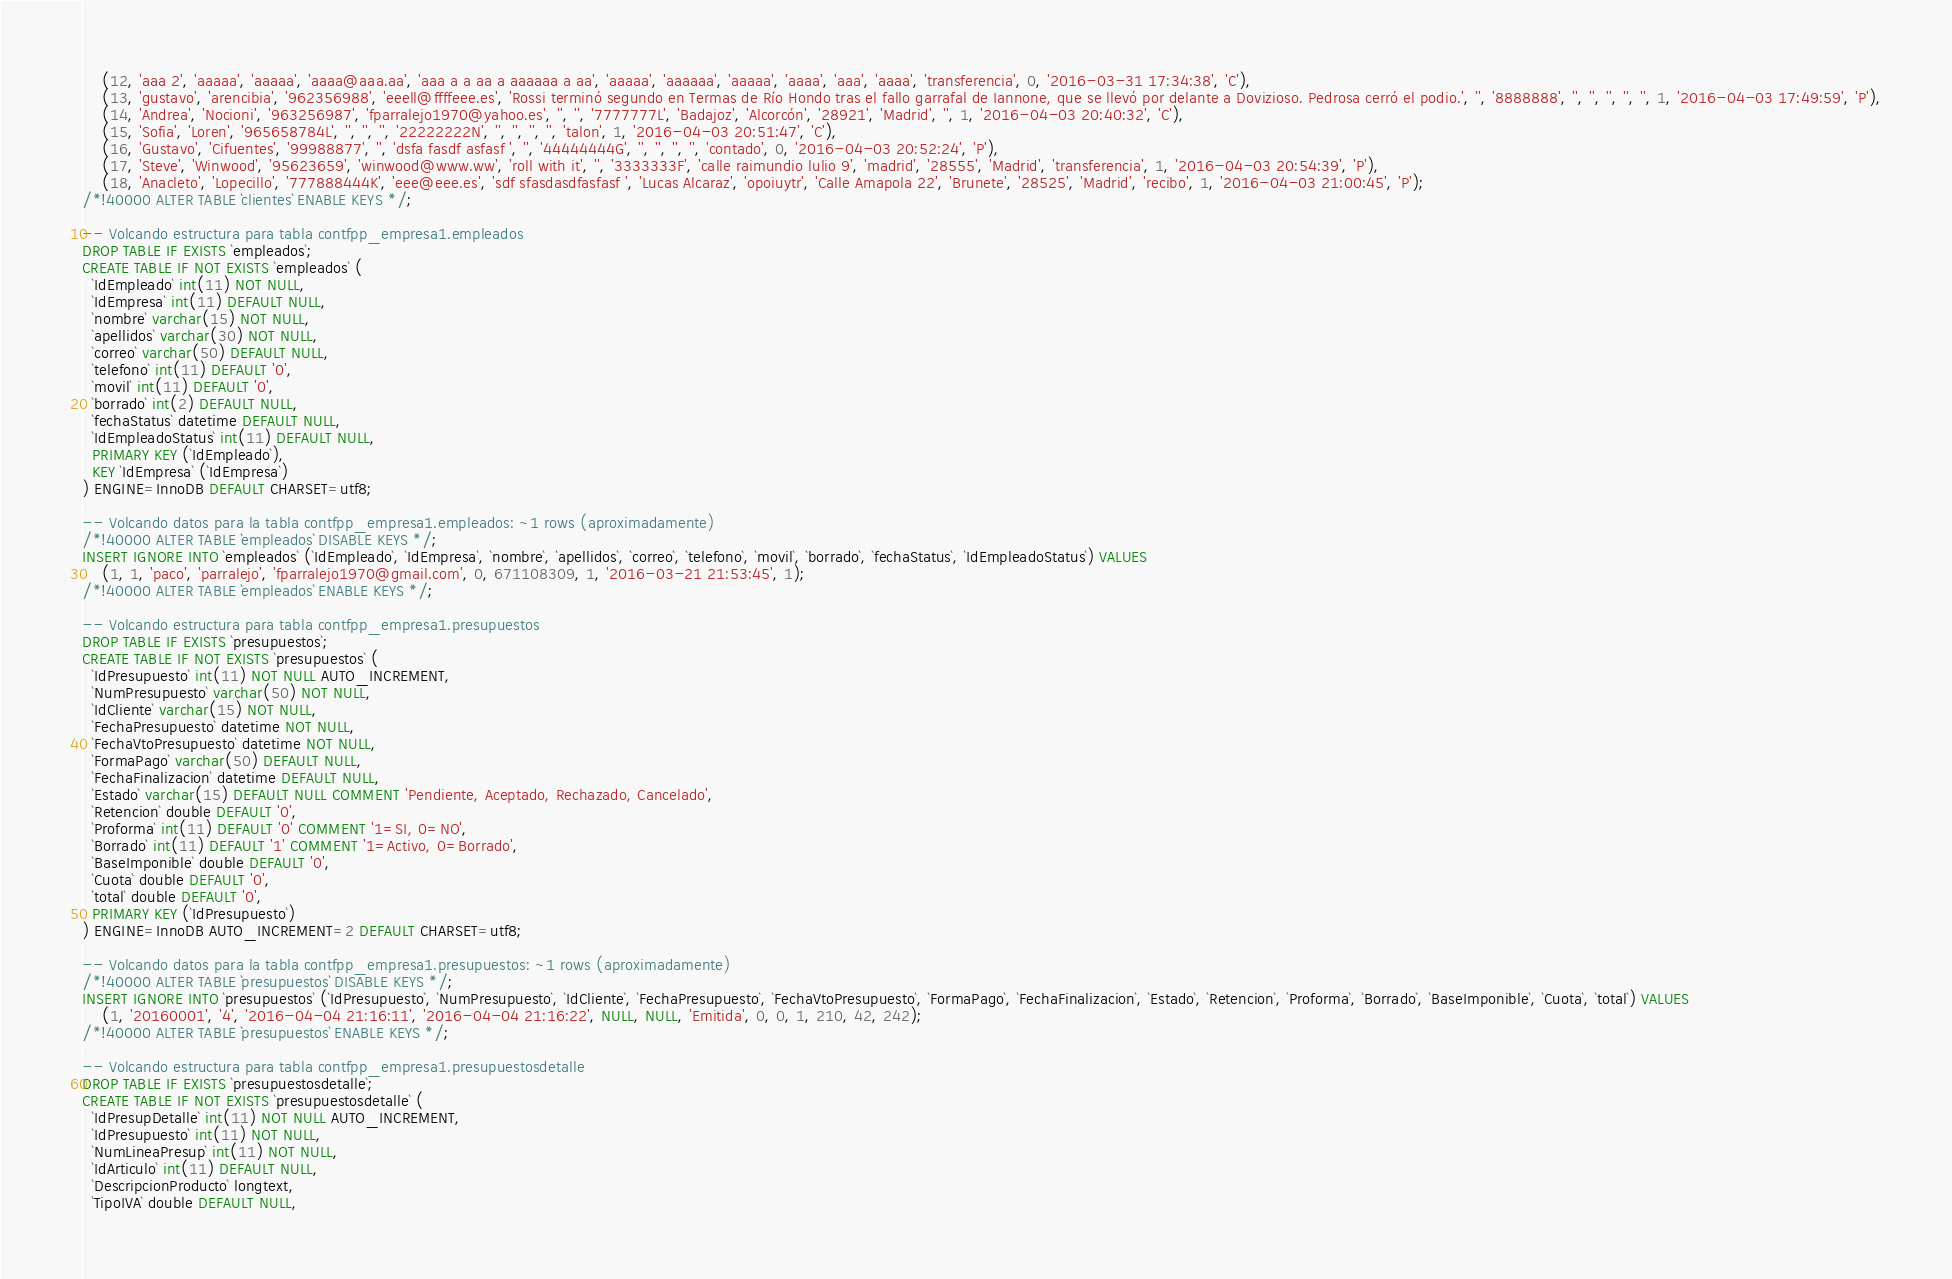Convert code to text. <code><loc_0><loc_0><loc_500><loc_500><_SQL_>	(12, 'aaa 2', 'aaaaa', 'aaaaa', 'aaaa@aaa.aa', 'aaa a a aa a aaaaaa a aa', 'aaaaa', 'aaaaaa', 'aaaaa', 'aaaa', 'aaa', 'aaaa', 'transferencia', 0, '2016-03-31 17:34:38', 'C'),
	(13, 'gustavo', 'arencibia', '962356988', 'eeell@ffffeee.es', 'Rossi terminó segundo en Termas de Río Hondo tras el fallo garrafal de Iannone, que se llevó por delante a Dovizioso. Pedrosa cerró el podio.', '', '8888888', '', '', '', '', '', 1, '2016-04-03 17:49:59', 'P'),
	(14, 'Andrea', 'Nocioni', '963256987', 'fparralejo1970@yahoo.es', '', '', '7777777L', 'Badajoz', 'Alcorcón', '28921', 'Madrid', '', 1, '2016-04-03 20:40:32', 'C'),
	(15, 'Sofia', 'Loren', '965658784L', '', '', '', '22222222N', '', '', '', '', 'talon', 1, '2016-04-03 20:51:47', 'C'),
	(16, 'Gustavo', 'Cifuentes', '99988877', '', 'dsfa fasdf asfasf ', '', '44444444G', '', '', '', '', 'contado', 0, '2016-04-03 20:52:24', 'P'),
	(17, 'Steve', 'Winwood', '95623659', 'winwood@www.ww', 'roll with it', '', '3333333F', 'calle raimundio lulio 9', 'madrid', '28555', 'Madrid', 'transferencia', 1, '2016-04-03 20:54:39', 'P'),
	(18, 'Anacleto', 'Lopecillo', '777888444K', 'eee@eee.es', 'sdf sfasdasdfasfasf ', 'Lucas Alcaraz', 'opoiuytr', 'Calle Amapola 22', 'Brunete', '28525', 'Madrid', 'recibo', 1, '2016-04-03 21:00:45', 'P');
/*!40000 ALTER TABLE `clientes` ENABLE KEYS */;

-- Volcando estructura para tabla contfpp_empresa1.empleados
DROP TABLE IF EXISTS `empleados`;
CREATE TABLE IF NOT EXISTS `empleados` (
  `IdEmpleado` int(11) NOT NULL,
  `IdEmpresa` int(11) DEFAULT NULL,
  `nombre` varchar(15) NOT NULL,
  `apellidos` varchar(30) NOT NULL,
  `correo` varchar(50) DEFAULT NULL,
  `telefono` int(11) DEFAULT '0',
  `movil` int(11) DEFAULT '0',
  `borrado` int(2) DEFAULT NULL,
  `fechaStatus` datetime DEFAULT NULL,
  `IdEmpleadoStatus` int(11) DEFAULT NULL,
  PRIMARY KEY (`IdEmpleado`),
  KEY `IdEmpresa` (`IdEmpresa`)
) ENGINE=InnoDB DEFAULT CHARSET=utf8;

-- Volcando datos para la tabla contfpp_empresa1.empleados: ~1 rows (aproximadamente)
/*!40000 ALTER TABLE `empleados` DISABLE KEYS */;
INSERT IGNORE INTO `empleados` (`IdEmpleado`, `IdEmpresa`, `nombre`, `apellidos`, `correo`, `telefono`, `movil`, `borrado`, `fechaStatus`, `IdEmpleadoStatus`) VALUES
	(1, 1, 'paco', 'parralejo', 'fparralejo1970@gmail.com', 0, 671108309, 1, '2016-03-21 21:53:45', 1);
/*!40000 ALTER TABLE `empleados` ENABLE KEYS */;

-- Volcando estructura para tabla contfpp_empresa1.presupuestos
DROP TABLE IF EXISTS `presupuestos`;
CREATE TABLE IF NOT EXISTS `presupuestos` (
  `IdPresupuesto` int(11) NOT NULL AUTO_INCREMENT,
  `NumPresupuesto` varchar(50) NOT NULL,
  `IdCliente` varchar(15) NOT NULL,
  `FechaPresupuesto` datetime NOT NULL,
  `FechaVtoPresupuesto` datetime NOT NULL,
  `FormaPago` varchar(50) DEFAULT NULL,
  `FechaFinalizacion` datetime DEFAULT NULL,
  `Estado` varchar(15) DEFAULT NULL COMMENT 'Pendiente, Aceptado, Rechazado, Cancelado',
  `Retencion` double DEFAULT '0',
  `Proforma` int(11) DEFAULT '0' COMMENT '1=SI, 0=NO',
  `Borrado` int(11) DEFAULT '1' COMMENT '1=Activo, 0=Borrado',
  `BaseImponible` double DEFAULT '0',
  `Cuota` double DEFAULT '0',
  `total` double DEFAULT '0',
  PRIMARY KEY (`IdPresupuesto`)
) ENGINE=InnoDB AUTO_INCREMENT=2 DEFAULT CHARSET=utf8;

-- Volcando datos para la tabla contfpp_empresa1.presupuestos: ~1 rows (aproximadamente)
/*!40000 ALTER TABLE `presupuestos` DISABLE KEYS */;
INSERT IGNORE INTO `presupuestos` (`IdPresupuesto`, `NumPresupuesto`, `IdCliente`, `FechaPresupuesto`, `FechaVtoPresupuesto`, `FormaPago`, `FechaFinalizacion`, `Estado`, `Retencion`, `Proforma`, `Borrado`, `BaseImponible`, `Cuota`, `total`) VALUES
	(1, '20160001', '4', '2016-04-04 21:16:11', '2016-04-04 21:16:22', NULL, NULL, 'Emitida', 0, 0, 1, 210, 42, 242);
/*!40000 ALTER TABLE `presupuestos` ENABLE KEYS */;

-- Volcando estructura para tabla contfpp_empresa1.presupuestosdetalle
DROP TABLE IF EXISTS `presupuestosdetalle`;
CREATE TABLE IF NOT EXISTS `presupuestosdetalle` (
  `IdPresupDetalle` int(11) NOT NULL AUTO_INCREMENT,
  `IdPresupuesto` int(11) NOT NULL,
  `NumLineaPresup` int(11) NOT NULL,
  `IdArticulo` int(11) DEFAULT NULL,
  `DescripcionProducto` longtext,
  `TipoIVA` double DEFAULT NULL,</code> 